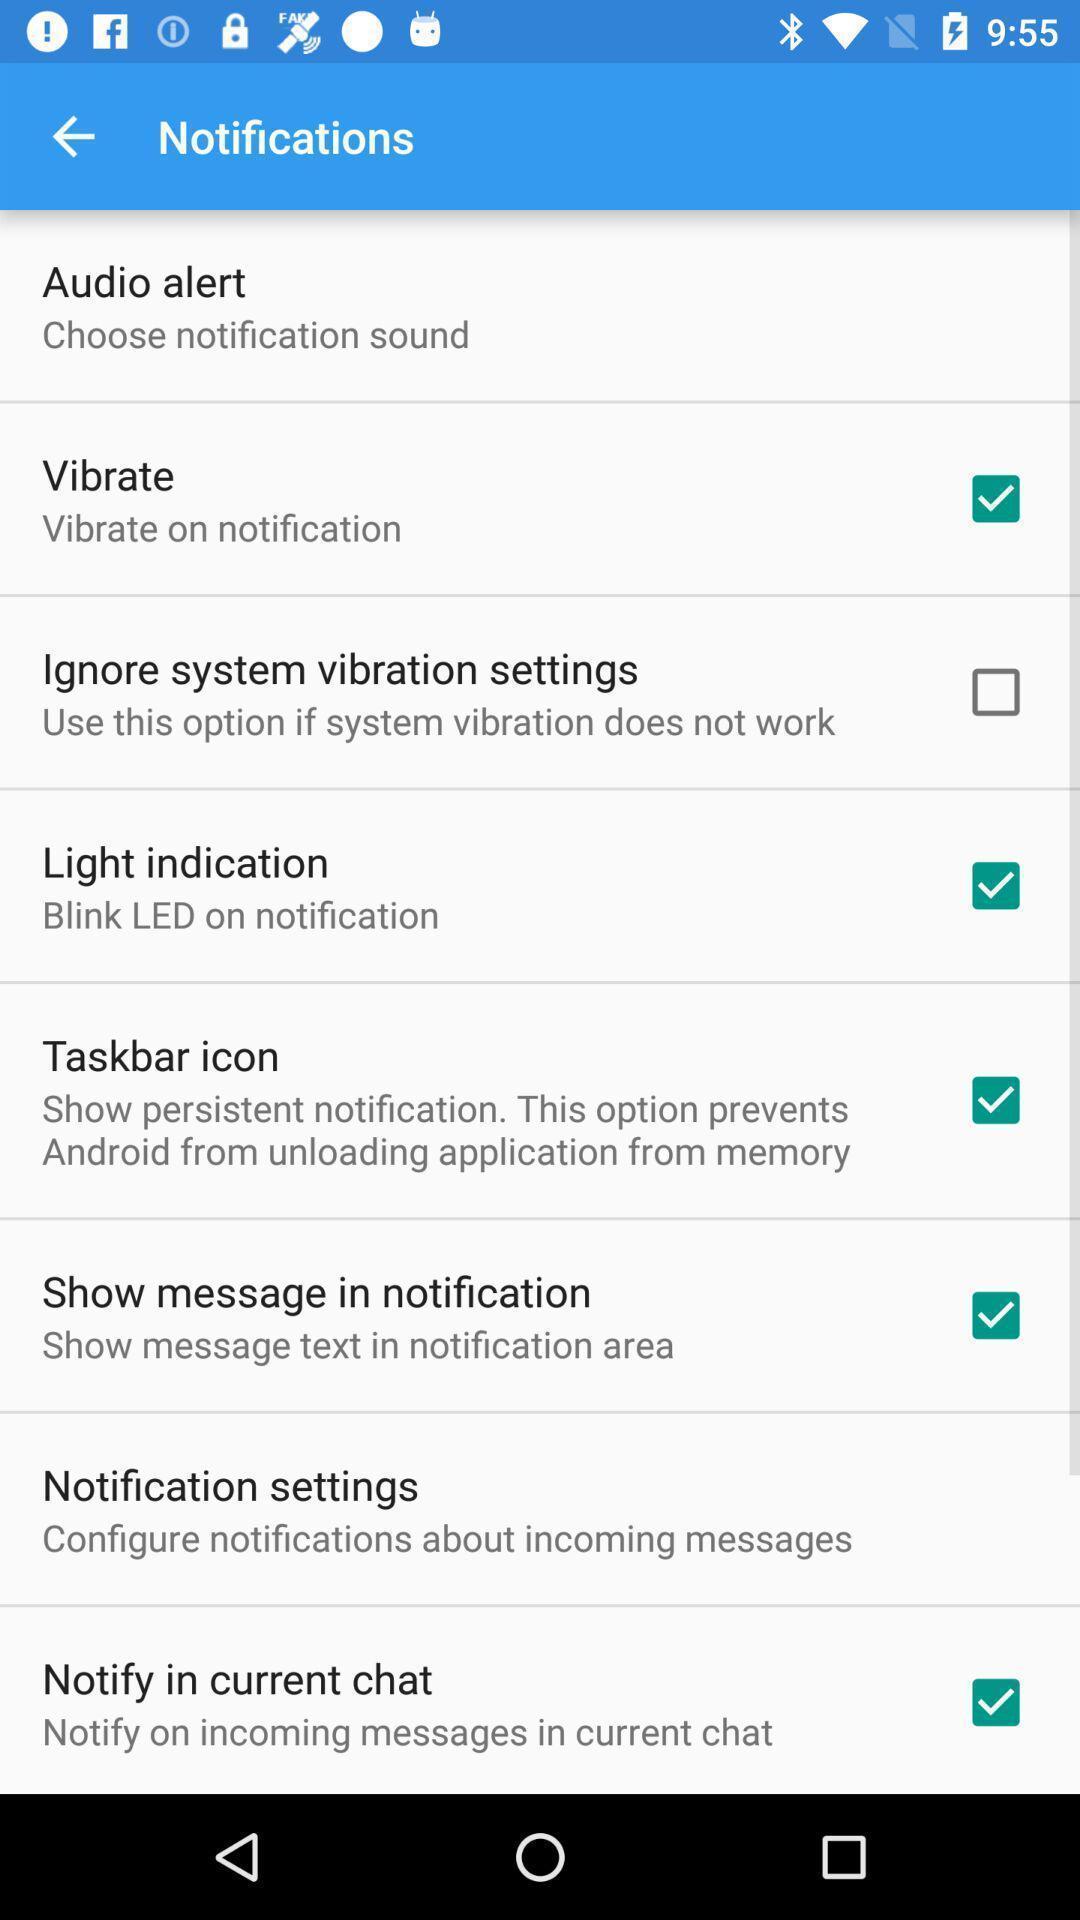Describe this image in words. Page showing the notification settings. 